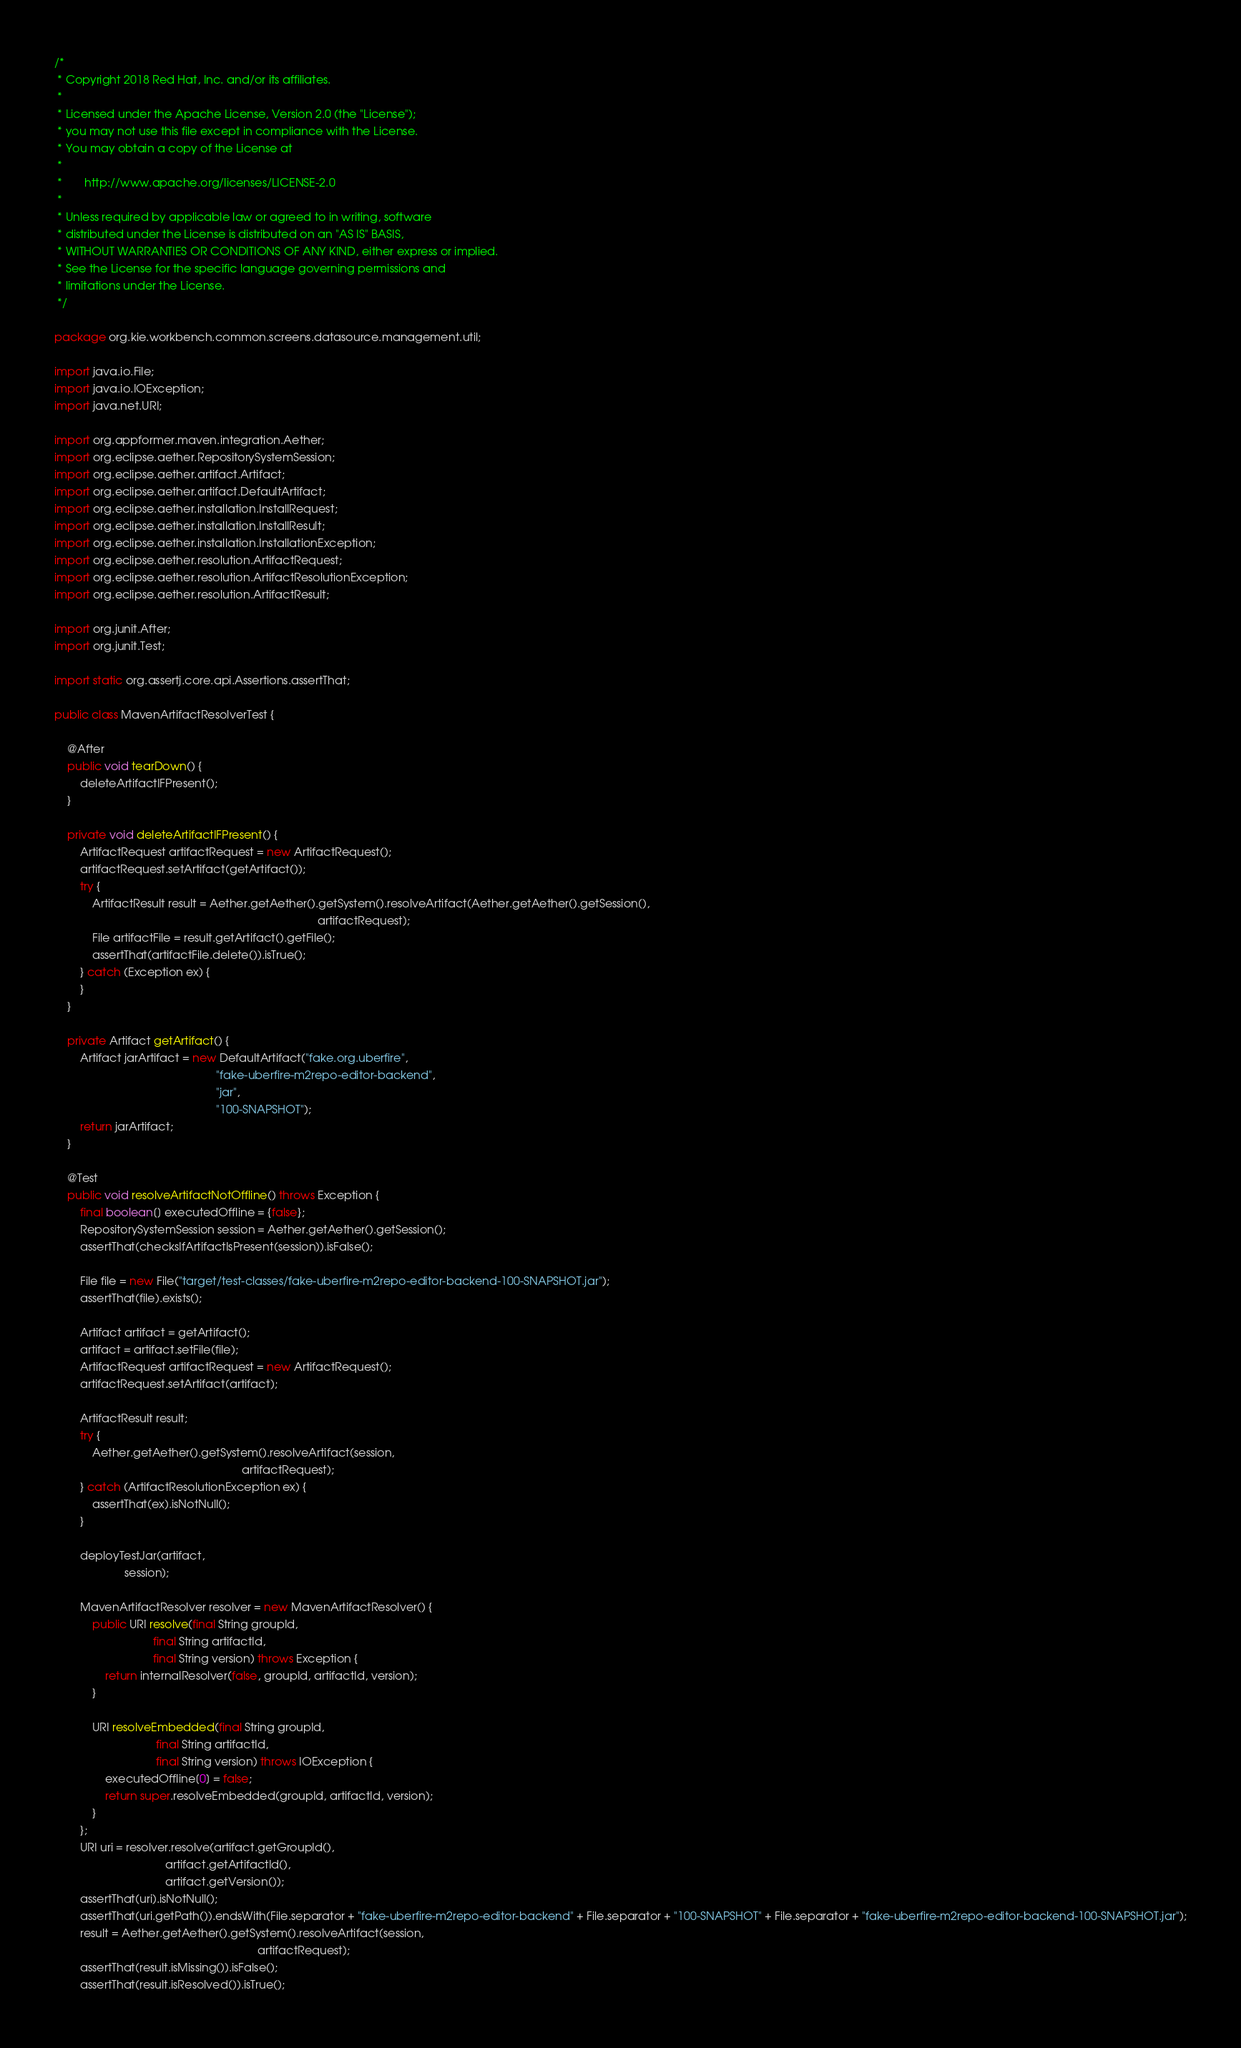<code> <loc_0><loc_0><loc_500><loc_500><_Java_>/*
 * Copyright 2018 Red Hat, Inc. and/or its affiliates.
 *
 * Licensed under the Apache License, Version 2.0 (the "License");
 * you may not use this file except in compliance with the License.
 * You may obtain a copy of the License at
 *
 *       http://www.apache.org/licenses/LICENSE-2.0
 *
 * Unless required by applicable law or agreed to in writing, software
 * distributed under the License is distributed on an "AS IS" BASIS,
 * WITHOUT WARRANTIES OR CONDITIONS OF ANY KIND, either express or implied.
 * See the License for the specific language governing permissions and
 * limitations under the License.
 */

package org.kie.workbench.common.screens.datasource.management.util;

import java.io.File;
import java.io.IOException;
import java.net.URI;

import org.appformer.maven.integration.Aether;
import org.eclipse.aether.RepositorySystemSession;
import org.eclipse.aether.artifact.Artifact;
import org.eclipse.aether.artifact.DefaultArtifact;
import org.eclipse.aether.installation.InstallRequest;
import org.eclipse.aether.installation.InstallResult;
import org.eclipse.aether.installation.InstallationException;
import org.eclipse.aether.resolution.ArtifactRequest;
import org.eclipse.aether.resolution.ArtifactResolutionException;
import org.eclipse.aether.resolution.ArtifactResult;

import org.junit.After;
import org.junit.Test;

import static org.assertj.core.api.Assertions.assertThat;

public class MavenArtifactResolverTest {

    @After
    public void tearDown() {
        deleteArtifactIFPresent();
    }

    private void deleteArtifactIFPresent() {
        ArtifactRequest artifactRequest = new ArtifactRequest();
        artifactRequest.setArtifact(getArtifact());
        try {
            ArtifactResult result = Aether.getAether().getSystem().resolveArtifact(Aether.getAether().getSession(),
                                                                                   artifactRequest);
            File artifactFile = result.getArtifact().getFile();
            assertThat(artifactFile.delete()).isTrue();
        } catch (Exception ex) {
        }
    }

    private Artifact getArtifact() {
        Artifact jarArtifact = new DefaultArtifact("fake.org.uberfire",
                                                   "fake-uberfire-m2repo-editor-backend",
                                                   "jar",
                                                   "100-SNAPSHOT");
        return jarArtifact;
    }

    @Test
    public void resolveArtifactNotOffline() throws Exception {
        final boolean[] executedOffline = {false};
        RepositorySystemSession session = Aether.getAether().getSession();
        assertThat(checksIfArtifactIsPresent(session)).isFalse();

        File file = new File("target/test-classes/fake-uberfire-m2repo-editor-backend-100-SNAPSHOT.jar");
        assertThat(file).exists();

        Artifact artifact = getArtifact();
        artifact = artifact.setFile(file);
        ArtifactRequest artifactRequest = new ArtifactRequest();
        artifactRequest.setArtifact(artifact);

        ArtifactResult result;
        try {
            Aether.getAether().getSystem().resolveArtifact(session,
                                                           artifactRequest);
        } catch (ArtifactResolutionException ex) {
            assertThat(ex).isNotNull();
        }

        deployTestJar(artifact,
                      session);

        MavenArtifactResolver resolver = new MavenArtifactResolver() {
            public URI resolve(final String groupId,
                               final String artifactId,
                               final String version) throws Exception {
                return internalResolver(false, groupId, artifactId, version);
            }

            URI resolveEmbedded(final String groupId,
                                final String artifactId,
                                final String version) throws IOException {
                executedOffline[0] = false;
                return super.resolveEmbedded(groupId, artifactId, version);
            }
        };
        URI uri = resolver.resolve(artifact.getGroupId(),
                                   artifact.getArtifactId(),
                                   artifact.getVersion());
        assertThat(uri).isNotNull();
        assertThat(uri.getPath()).endsWith(File.separator + "fake-uberfire-m2repo-editor-backend" + File.separator + "100-SNAPSHOT" + File.separator + "fake-uberfire-m2repo-editor-backend-100-SNAPSHOT.jar");
        result = Aether.getAether().getSystem().resolveArtifact(session,
                                                                artifactRequest);
        assertThat(result.isMissing()).isFalse();
        assertThat(result.isResolved()).isTrue();</code> 